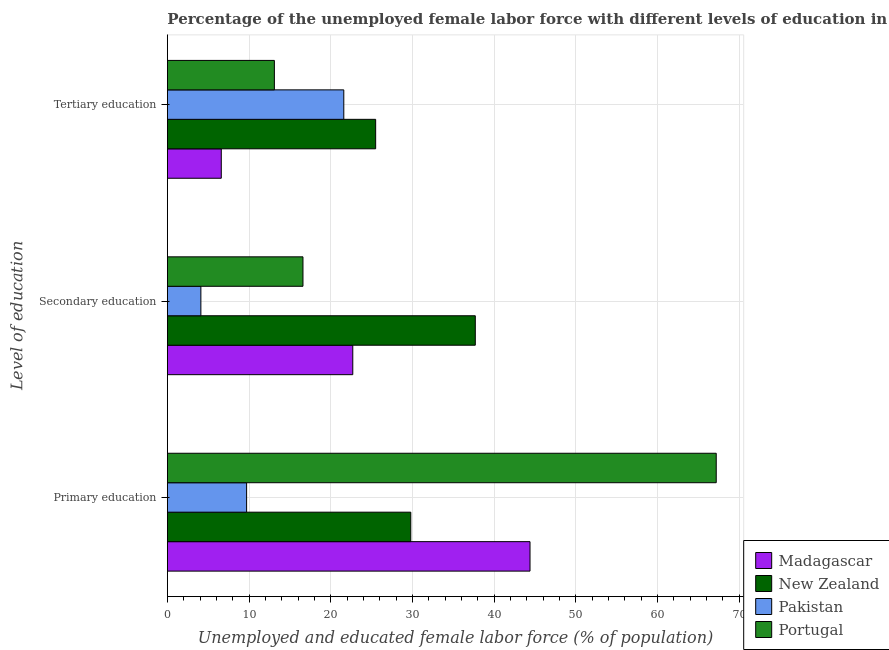How many different coloured bars are there?
Give a very brief answer. 4. How many groups of bars are there?
Ensure brevity in your answer.  3. Are the number of bars per tick equal to the number of legend labels?
Keep it short and to the point. Yes. How many bars are there on the 3rd tick from the bottom?
Ensure brevity in your answer.  4. What is the label of the 1st group of bars from the top?
Offer a very short reply. Tertiary education. What is the percentage of female labor force who received secondary education in Portugal?
Offer a terse response. 16.6. Across all countries, what is the maximum percentage of female labor force who received primary education?
Provide a succinct answer. 67.2. Across all countries, what is the minimum percentage of female labor force who received primary education?
Your answer should be compact. 9.7. In which country was the percentage of female labor force who received primary education maximum?
Provide a succinct answer. Portugal. In which country was the percentage of female labor force who received primary education minimum?
Your response must be concise. Pakistan. What is the total percentage of female labor force who received secondary education in the graph?
Ensure brevity in your answer.  81.1. What is the difference between the percentage of female labor force who received secondary education in Madagascar and that in Pakistan?
Your answer should be very brief. 18.6. What is the difference between the percentage of female labor force who received secondary education in Portugal and the percentage of female labor force who received primary education in Pakistan?
Provide a short and direct response. 6.9. What is the average percentage of female labor force who received secondary education per country?
Offer a very short reply. 20.28. What is the difference between the percentage of female labor force who received primary education and percentage of female labor force who received tertiary education in Portugal?
Keep it short and to the point. 54.1. In how many countries, is the percentage of female labor force who received tertiary education greater than 50 %?
Ensure brevity in your answer.  0. What is the ratio of the percentage of female labor force who received primary education in New Zealand to that in Portugal?
Your answer should be very brief. 0.44. Is the percentage of female labor force who received primary education in Madagascar less than that in New Zealand?
Offer a terse response. No. What is the difference between the highest and the second highest percentage of female labor force who received tertiary education?
Provide a short and direct response. 3.9. What is the difference between the highest and the lowest percentage of female labor force who received secondary education?
Make the answer very short. 33.6. Is it the case that in every country, the sum of the percentage of female labor force who received primary education and percentage of female labor force who received secondary education is greater than the percentage of female labor force who received tertiary education?
Your answer should be compact. No. How many countries are there in the graph?
Your response must be concise. 4. Are the values on the major ticks of X-axis written in scientific E-notation?
Offer a terse response. No. Does the graph contain any zero values?
Offer a very short reply. No. Where does the legend appear in the graph?
Offer a terse response. Bottom right. How many legend labels are there?
Your answer should be compact. 4. How are the legend labels stacked?
Ensure brevity in your answer.  Vertical. What is the title of the graph?
Provide a short and direct response. Percentage of the unemployed female labor force with different levels of education in countries. Does "East Asia (developing only)" appear as one of the legend labels in the graph?
Provide a succinct answer. No. What is the label or title of the X-axis?
Provide a succinct answer. Unemployed and educated female labor force (% of population). What is the label or title of the Y-axis?
Offer a very short reply. Level of education. What is the Unemployed and educated female labor force (% of population) in Madagascar in Primary education?
Offer a very short reply. 44.4. What is the Unemployed and educated female labor force (% of population) in New Zealand in Primary education?
Offer a very short reply. 29.8. What is the Unemployed and educated female labor force (% of population) of Pakistan in Primary education?
Make the answer very short. 9.7. What is the Unemployed and educated female labor force (% of population) of Portugal in Primary education?
Your response must be concise. 67.2. What is the Unemployed and educated female labor force (% of population) of Madagascar in Secondary education?
Offer a terse response. 22.7. What is the Unemployed and educated female labor force (% of population) of New Zealand in Secondary education?
Your answer should be very brief. 37.7. What is the Unemployed and educated female labor force (% of population) in Pakistan in Secondary education?
Give a very brief answer. 4.1. What is the Unemployed and educated female labor force (% of population) of Portugal in Secondary education?
Give a very brief answer. 16.6. What is the Unemployed and educated female labor force (% of population) of Madagascar in Tertiary education?
Offer a very short reply. 6.6. What is the Unemployed and educated female labor force (% of population) of Pakistan in Tertiary education?
Keep it short and to the point. 21.6. What is the Unemployed and educated female labor force (% of population) in Portugal in Tertiary education?
Provide a short and direct response. 13.1. Across all Level of education, what is the maximum Unemployed and educated female labor force (% of population) in Madagascar?
Keep it short and to the point. 44.4. Across all Level of education, what is the maximum Unemployed and educated female labor force (% of population) in New Zealand?
Offer a terse response. 37.7. Across all Level of education, what is the maximum Unemployed and educated female labor force (% of population) in Pakistan?
Offer a very short reply. 21.6. Across all Level of education, what is the maximum Unemployed and educated female labor force (% of population) in Portugal?
Provide a short and direct response. 67.2. Across all Level of education, what is the minimum Unemployed and educated female labor force (% of population) of Madagascar?
Offer a terse response. 6.6. Across all Level of education, what is the minimum Unemployed and educated female labor force (% of population) in New Zealand?
Ensure brevity in your answer.  25.5. Across all Level of education, what is the minimum Unemployed and educated female labor force (% of population) of Pakistan?
Give a very brief answer. 4.1. Across all Level of education, what is the minimum Unemployed and educated female labor force (% of population) in Portugal?
Your response must be concise. 13.1. What is the total Unemployed and educated female labor force (% of population) in Madagascar in the graph?
Ensure brevity in your answer.  73.7. What is the total Unemployed and educated female labor force (% of population) of New Zealand in the graph?
Your answer should be compact. 93. What is the total Unemployed and educated female labor force (% of population) in Pakistan in the graph?
Ensure brevity in your answer.  35.4. What is the total Unemployed and educated female labor force (% of population) in Portugal in the graph?
Offer a terse response. 96.9. What is the difference between the Unemployed and educated female labor force (% of population) in Madagascar in Primary education and that in Secondary education?
Ensure brevity in your answer.  21.7. What is the difference between the Unemployed and educated female labor force (% of population) of New Zealand in Primary education and that in Secondary education?
Make the answer very short. -7.9. What is the difference between the Unemployed and educated female labor force (% of population) of Pakistan in Primary education and that in Secondary education?
Provide a succinct answer. 5.6. What is the difference between the Unemployed and educated female labor force (% of population) in Portugal in Primary education and that in Secondary education?
Provide a succinct answer. 50.6. What is the difference between the Unemployed and educated female labor force (% of population) in Madagascar in Primary education and that in Tertiary education?
Ensure brevity in your answer.  37.8. What is the difference between the Unemployed and educated female labor force (% of population) in Pakistan in Primary education and that in Tertiary education?
Provide a short and direct response. -11.9. What is the difference between the Unemployed and educated female labor force (% of population) of Portugal in Primary education and that in Tertiary education?
Your answer should be compact. 54.1. What is the difference between the Unemployed and educated female labor force (% of population) of New Zealand in Secondary education and that in Tertiary education?
Keep it short and to the point. 12.2. What is the difference between the Unemployed and educated female labor force (% of population) in Pakistan in Secondary education and that in Tertiary education?
Your response must be concise. -17.5. What is the difference between the Unemployed and educated female labor force (% of population) in Portugal in Secondary education and that in Tertiary education?
Offer a terse response. 3.5. What is the difference between the Unemployed and educated female labor force (% of population) of Madagascar in Primary education and the Unemployed and educated female labor force (% of population) of New Zealand in Secondary education?
Give a very brief answer. 6.7. What is the difference between the Unemployed and educated female labor force (% of population) in Madagascar in Primary education and the Unemployed and educated female labor force (% of population) in Pakistan in Secondary education?
Make the answer very short. 40.3. What is the difference between the Unemployed and educated female labor force (% of population) in Madagascar in Primary education and the Unemployed and educated female labor force (% of population) in Portugal in Secondary education?
Make the answer very short. 27.8. What is the difference between the Unemployed and educated female labor force (% of population) in New Zealand in Primary education and the Unemployed and educated female labor force (% of population) in Pakistan in Secondary education?
Give a very brief answer. 25.7. What is the difference between the Unemployed and educated female labor force (% of population) of Pakistan in Primary education and the Unemployed and educated female labor force (% of population) of Portugal in Secondary education?
Ensure brevity in your answer.  -6.9. What is the difference between the Unemployed and educated female labor force (% of population) of Madagascar in Primary education and the Unemployed and educated female labor force (% of population) of Pakistan in Tertiary education?
Provide a succinct answer. 22.8. What is the difference between the Unemployed and educated female labor force (% of population) in Madagascar in Primary education and the Unemployed and educated female labor force (% of population) in Portugal in Tertiary education?
Offer a very short reply. 31.3. What is the difference between the Unemployed and educated female labor force (% of population) in New Zealand in Primary education and the Unemployed and educated female labor force (% of population) in Portugal in Tertiary education?
Ensure brevity in your answer.  16.7. What is the difference between the Unemployed and educated female labor force (% of population) of Pakistan in Primary education and the Unemployed and educated female labor force (% of population) of Portugal in Tertiary education?
Offer a very short reply. -3.4. What is the difference between the Unemployed and educated female labor force (% of population) in Madagascar in Secondary education and the Unemployed and educated female labor force (% of population) in Portugal in Tertiary education?
Provide a succinct answer. 9.6. What is the difference between the Unemployed and educated female labor force (% of population) in New Zealand in Secondary education and the Unemployed and educated female labor force (% of population) in Pakistan in Tertiary education?
Give a very brief answer. 16.1. What is the difference between the Unemployed and educated female labor force (% of population) of New Zealand in Secondary education and the Unemployed and educated female labor force (% of population) of Portugal in Tertiary education?
Give a very brief answer. 24.6. What is the difference between the Unemployed and educated female labor force (% of population) of Pakistan in Secondary education and the Unemployed and educated female labor force (% of population) of Portugal in Tertiary education?
Offer a terse response. -9. What is the average Unemployed and educated female labor force (% of population) of Madagascar per Level of education?
Provide a short and direct response. 24.57. What is the average Unemployed and educated female labor force (% of population) of Portugal per Level of education?
Your answer should be compact. 32.3. What is the difference between the Unemployed and educated female labor force (% of population) in Madagascar and Unemployed and educated female labor force (% of population) in New Zealand in Primary education?
Ensure brevity in your answer.  14.6. What is the difference between the Unemployed and educated female labor force (% of population) of Madagascar and Unemployed and educated female labor force (% of population) of Pakistan in Primary education?
Give a very brief answer. 34.7. What is the difference between the Unemployed and educated female labor force (% of population) of Madagascar and Unemployed and educated female labor force (% of population) of Portugal in Primary education?
Give a very brief answer. -22.8. What is the difference between the Unemployed and educated female labor force (% of population) in New Zealand and Unemployed and educated female labor force (% of population) in Pakistan in Primary education?
Ensure brevity in your answer.  20.1. What is the difference between the Unemployed and educated female labor force (% of population) in New Zealand and Unemployed and educated female labor force (% of population) in Portugal in Primary education?
Provide a short and direct response. -37.4. What is the difference between the Unemployed and educated female labor force (% of population) in Pakistan and Unemployed and educated female labor force (% of population) in Portugal in Primary education?
Offer a terse response. -57.5. What is the difference between the Unemployed and educated female labor force (% of population) in Madagascar and Unemployed and educated female labor force (% of population) in New Zealand in Secondary education?
Your answer should be very brief. -15. What is the difference between the Unemployed and educated female labor force (% of population) of New Zealand and Unemployed and educated female labor force (% of population) of Pakistan in Secondary education?
Provide a short and direct response. 33.6. What is the difference between the Unemployed and educated female labor force (% of population) of New Zealand and Unemployed and educated female labor force (% of population) of Portugal in Secondary education?
Provide a succinct answer. 21.1. What is the difference between the Unemployed and educated female labor force (% of population) of Pakistan and Unemployed and educated female labor force (% of population) of Portugal in Secondary education?
Provide a succinct answer. -12.5. What is the difference between the Unemployed and educated female labor force (% of population) of Madagascar and Unemployed and educated female labor force (% of population) of New Zealand in Tertiary education?
Provide a short and direct response. -18.9. What is the difference between the Unemployed and educated female labor force (% of population) in Madagascar and Unemployed and educated female labor force (% of population) in Portugal in Tertiary education?
Make the answer very short. -6.5. What is the difference between the Unemployed and educated female labor force (% of population) of New Zealand and Unemployed and educated female labor force (% of population) of Pakistan in Tertiary education?
Your answer should be compact. 3.9. What is the ratio of the Unemployed and educated female labor force (% of population) of Madagascar in Primary education to that in Secondary education?
Your answer should be compact. 1.96. What is the ratio of the Unemployed and educated female labor force (% of population) of New Zealand in Primary education to that in Secondary education?
Ensure brevity in your answer.  0.79. What is the ratio of the Unemployed and educated female labor force (% of population) of Pakistan in Primary education to that in Secondary education?
Ensure brevity in your answer.  2.37. What is the ratio of the Unemployed and educated female labor force (% of population) of Portugal in Primary education to that in Secondary education?
Offer a terse response. 4.05. What is the ratio of the Unemployed and educated female labor force (% of population) in Madagascar in Primary education to that in Tertiary education?
Offer a very short reply. 6.73. What is the ratio of the Unemployed and educated female labor force (% of population) in New Zealand in Primary education to that in Tertiary education?
Your answer should be compact. 1.17. What is the ratio of the Unemployed and educated female labor force (% of population) of Pakistan in Primary education to that in Tertiary education?
Ensure brevity in your answer.  0.45. What is the ratio of the Unemployed and educated female labor force (% of population) of Portugal in Primary education to that in Tertiary education?
Offer a very short reply. 5.13. What is the ratio of the Unemployed and educated female labor force (% of population) in Madagascar in Secondary education to that in Tertiary education?
Ensure brevity in your answer.  3.44. What is the ratio of the Unemployed and educated female labor force (% of population) of New Zealand in Secondary education to that in Tertiary education?
Ensure brevity in your answer.  1.48. What is the ratio of the Unemployed and educated female labor force (% of population) in Pakistan in Secondary education to that in Tertiary education?
Provide a short and direct response. 0.19. What is the ratio of the Unemployed and educated female labor force (% of population) in Portugal in Secondary education to that in Tertiary education?
Offer a terse response. 1.27. What is the difference between the highest and the second highest Unemployed and educated female labor force (% of population) of Madagascar?
Ensure brevity in your answer.  21.7. What is the difference between the highest and the second highest Unemployed and educated female labor force (% of population) in Portugal?
Provide a succinct answer. 50.6. What is the difference between the highest and the lowest Unemployed and educated female labor force (% of population) in Madagascar?
Your answer should be compact. 37.8. What is the difference between the highest and the lowest Unemployed and educated female labor force (% of population) of Pakistan?
Your answer should be very brief. 17.5. What is the difference between the highest and the lowest Unemployed and educated female labor force (% of population) of Portugal?
Your answer should be very brief. 54.1. 